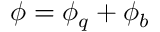Convert formula to latex. <formula><loc_0><loc_0><loc_500><loc_500>\phi = \phi _ { q } + \phi _ { b }</formula> 